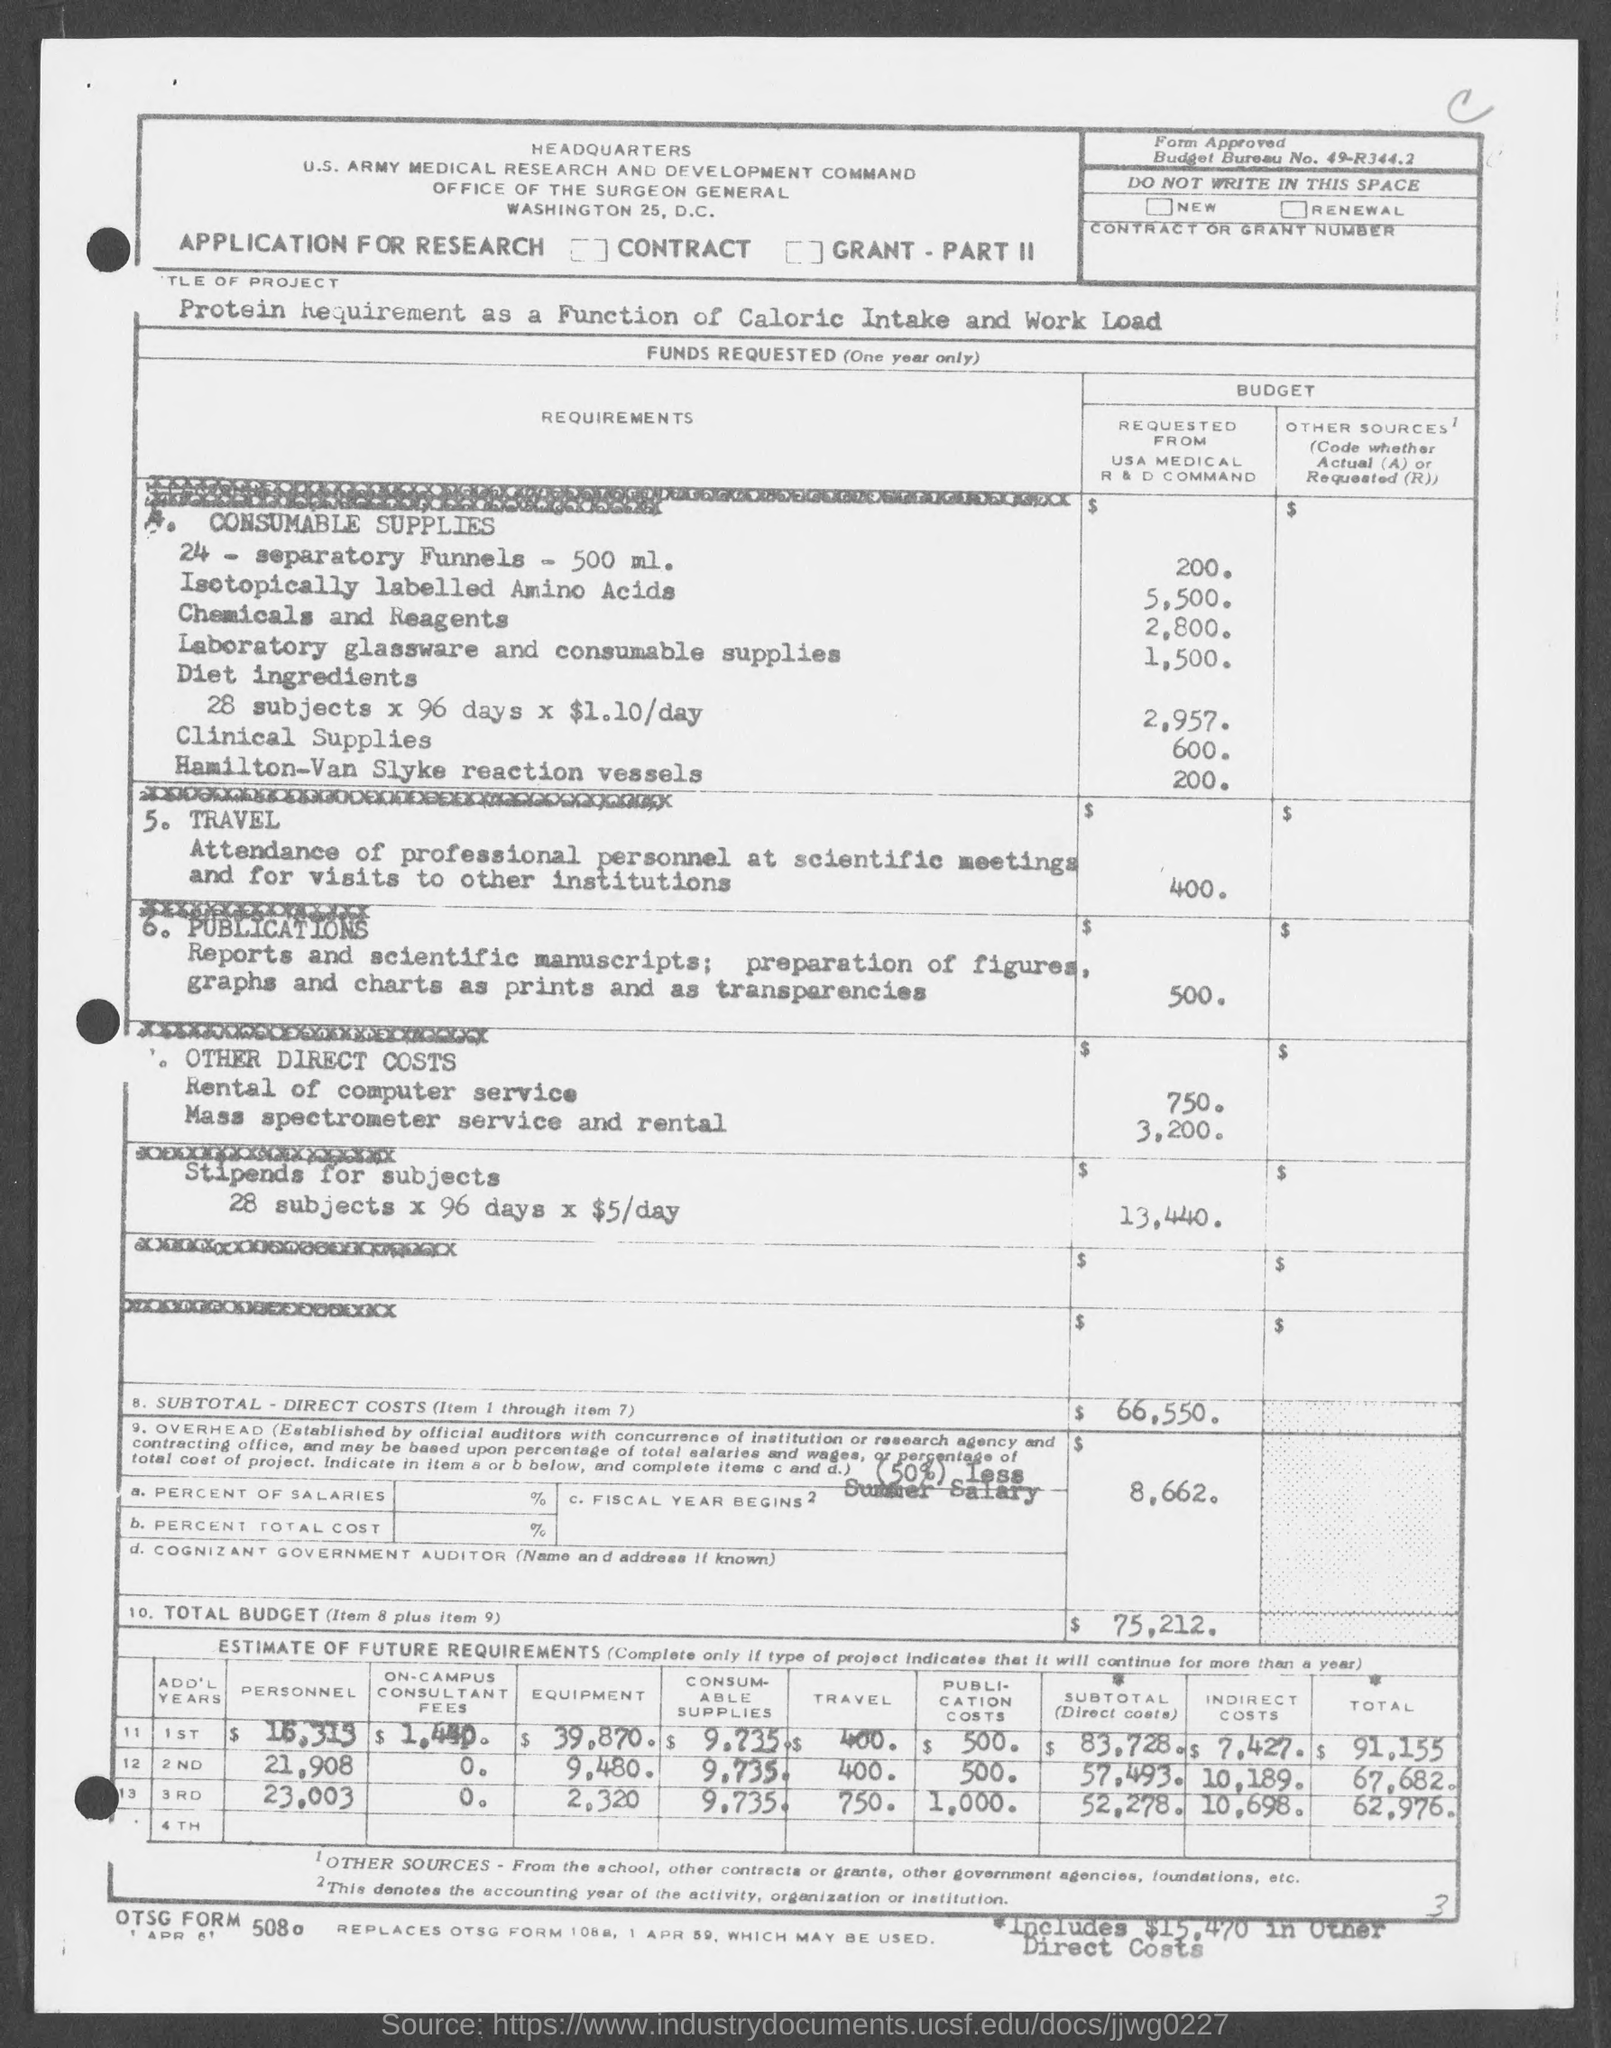Specify some key components in this picture. The budget for clinical supplies is approximately 600. The budget for Hamilton-Van Slyke reaction vessels is currently set at 200... The budget for diet ingredients for 28 subjects over % days at $1.10/day is $2,957. The budget for laboratory glassware and consumable supplies is set at 1,500. The budget for 24 separatory funnels is 200... 